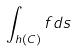<formula> <loc_0><loc_0><loc_500><loc_500>\int _ { h ( C ) } f d s</formula> 